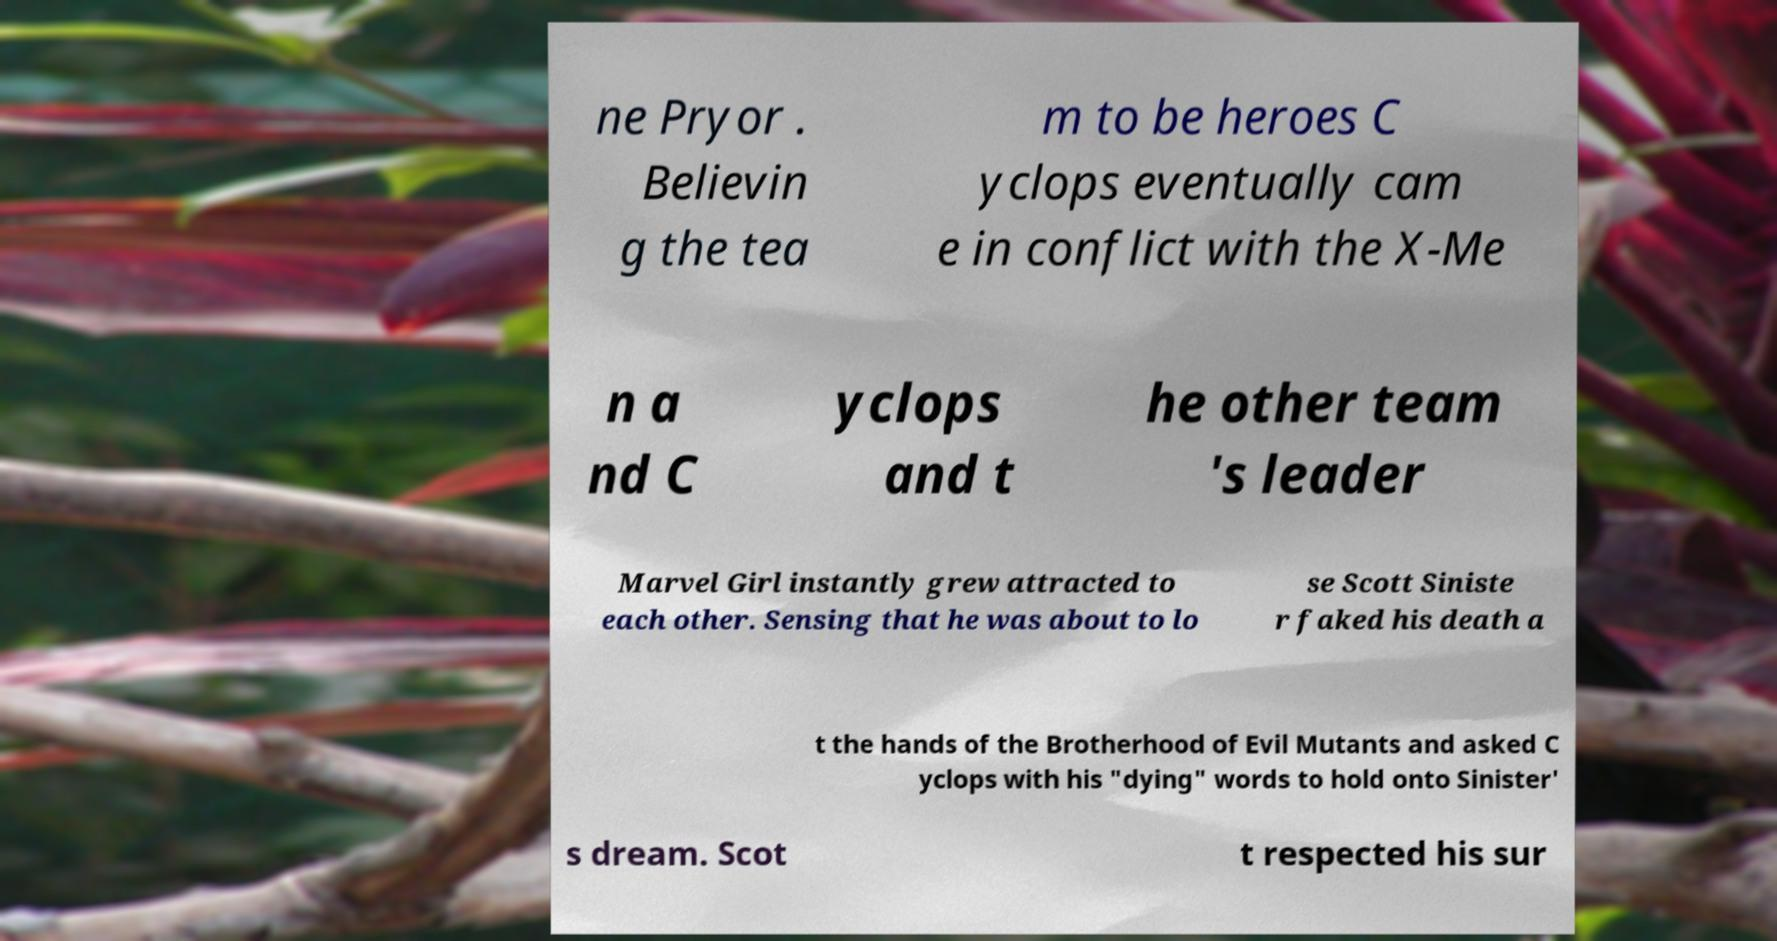Can you read and provide the text displayed in the image?This photo seems to have some interesting text. Can you extract and type it out for me? ne Pryor . Believin g the tea m to be heroes C yclops eventually cam e in conflict with the X-Me n a nd C yclops and t he other team 's leader Marvel Girl instantly grew attracted to each other. Sensing that he was about to lo se Scott Siniste r faked his death a t the hands of the Brotherhood of Evil Mutants and asked C yclops with his "dying" words to hold onto Sinister' s dream. Scot t respected his sur 